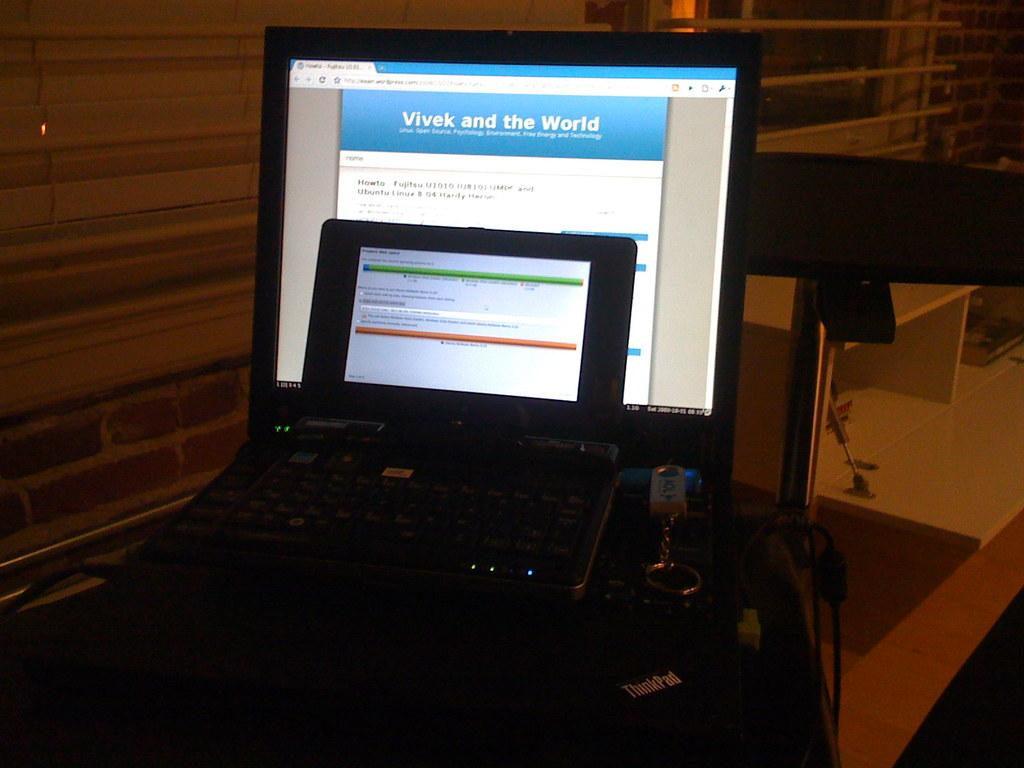<image>
Create a compact narrative representing the image presented. the word world is on the laptop on the table 